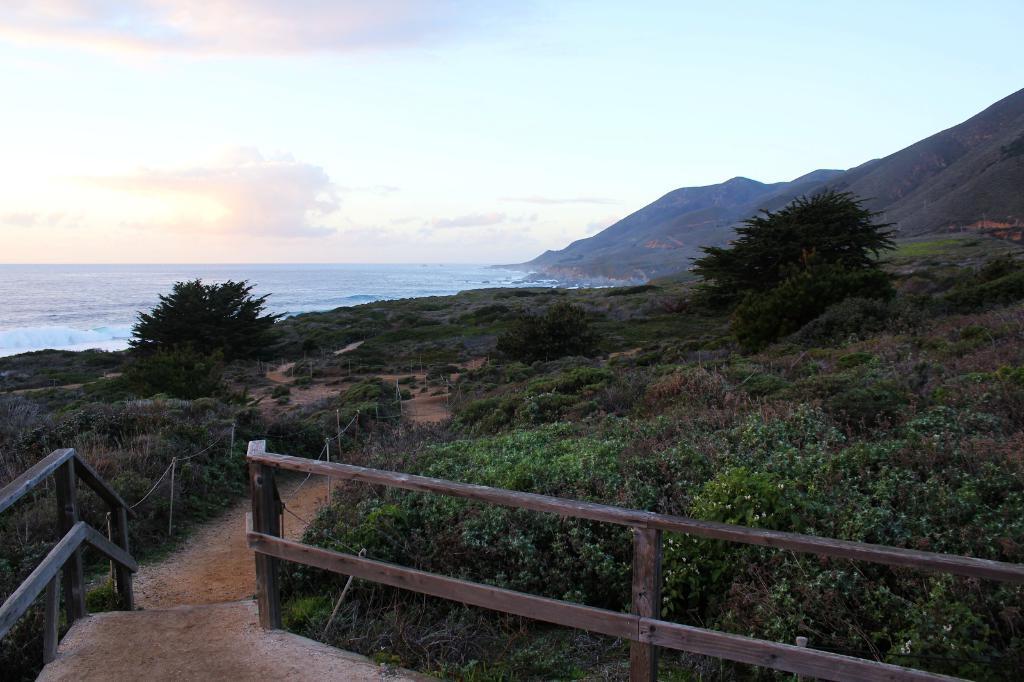Could you give a brief overview of what you see in this image? In this image we can see an ocean, mountains, trees, plants, land covered with grass and railing. The sky is in blue color with some clouds. 